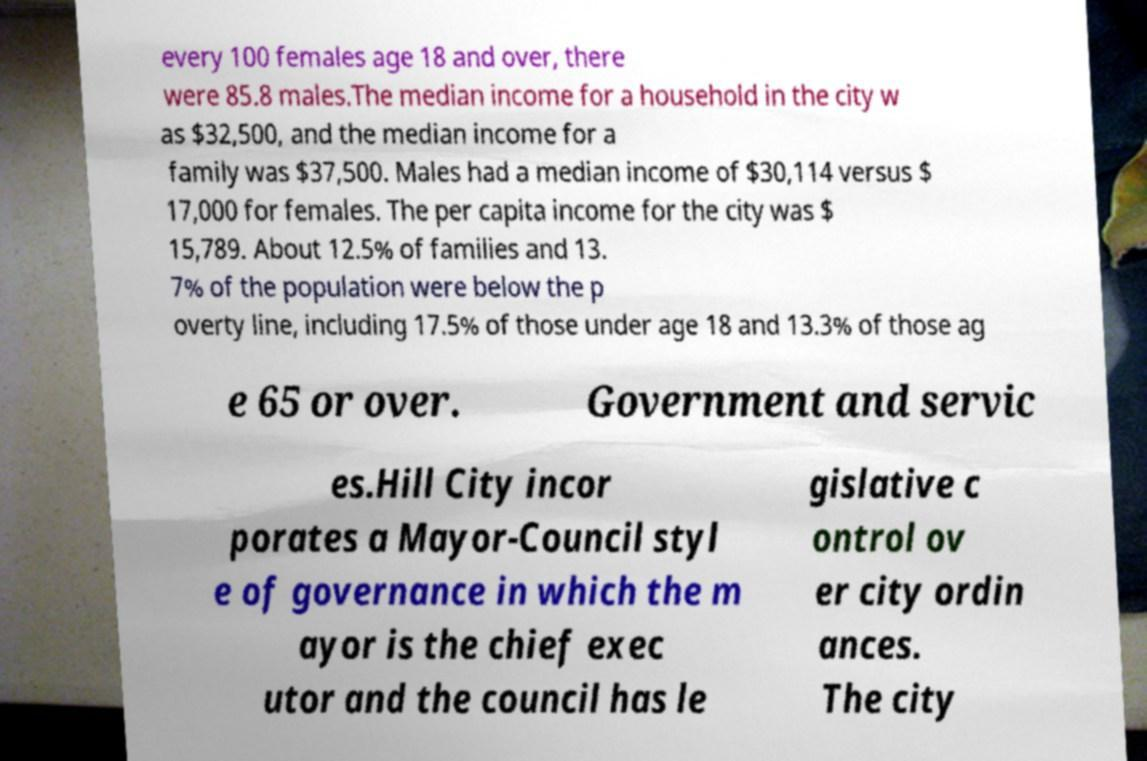What messages or text are displayed in this image? I need them in a readable, typed format. every 100 females age 18 and over, there were 85.8 males.The median income for a household in the city w as $32,500, and the median income for a family was $37,500. Males had a median income of $30,114 versus $ 17,000 for females. The per capita income for the city was $ 15,789. About 12.5% of families and 13. 7% of the population were below the p overty line, including 17.5% of those under age 18 and 13.3% of those ag e 65 or over. Government and servic es.Hill City incor porates a Mayor-Council styl e of governance in which the m ayor is the chief exec utor and the council has le gislative c ontrol ov er city ordin ances. The city 